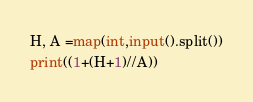<code> <loc_0><loc_0><loc_500><loc_500><_Python_>H, A =map(int,input().split())
print((1+(H+1)//A))</code> 